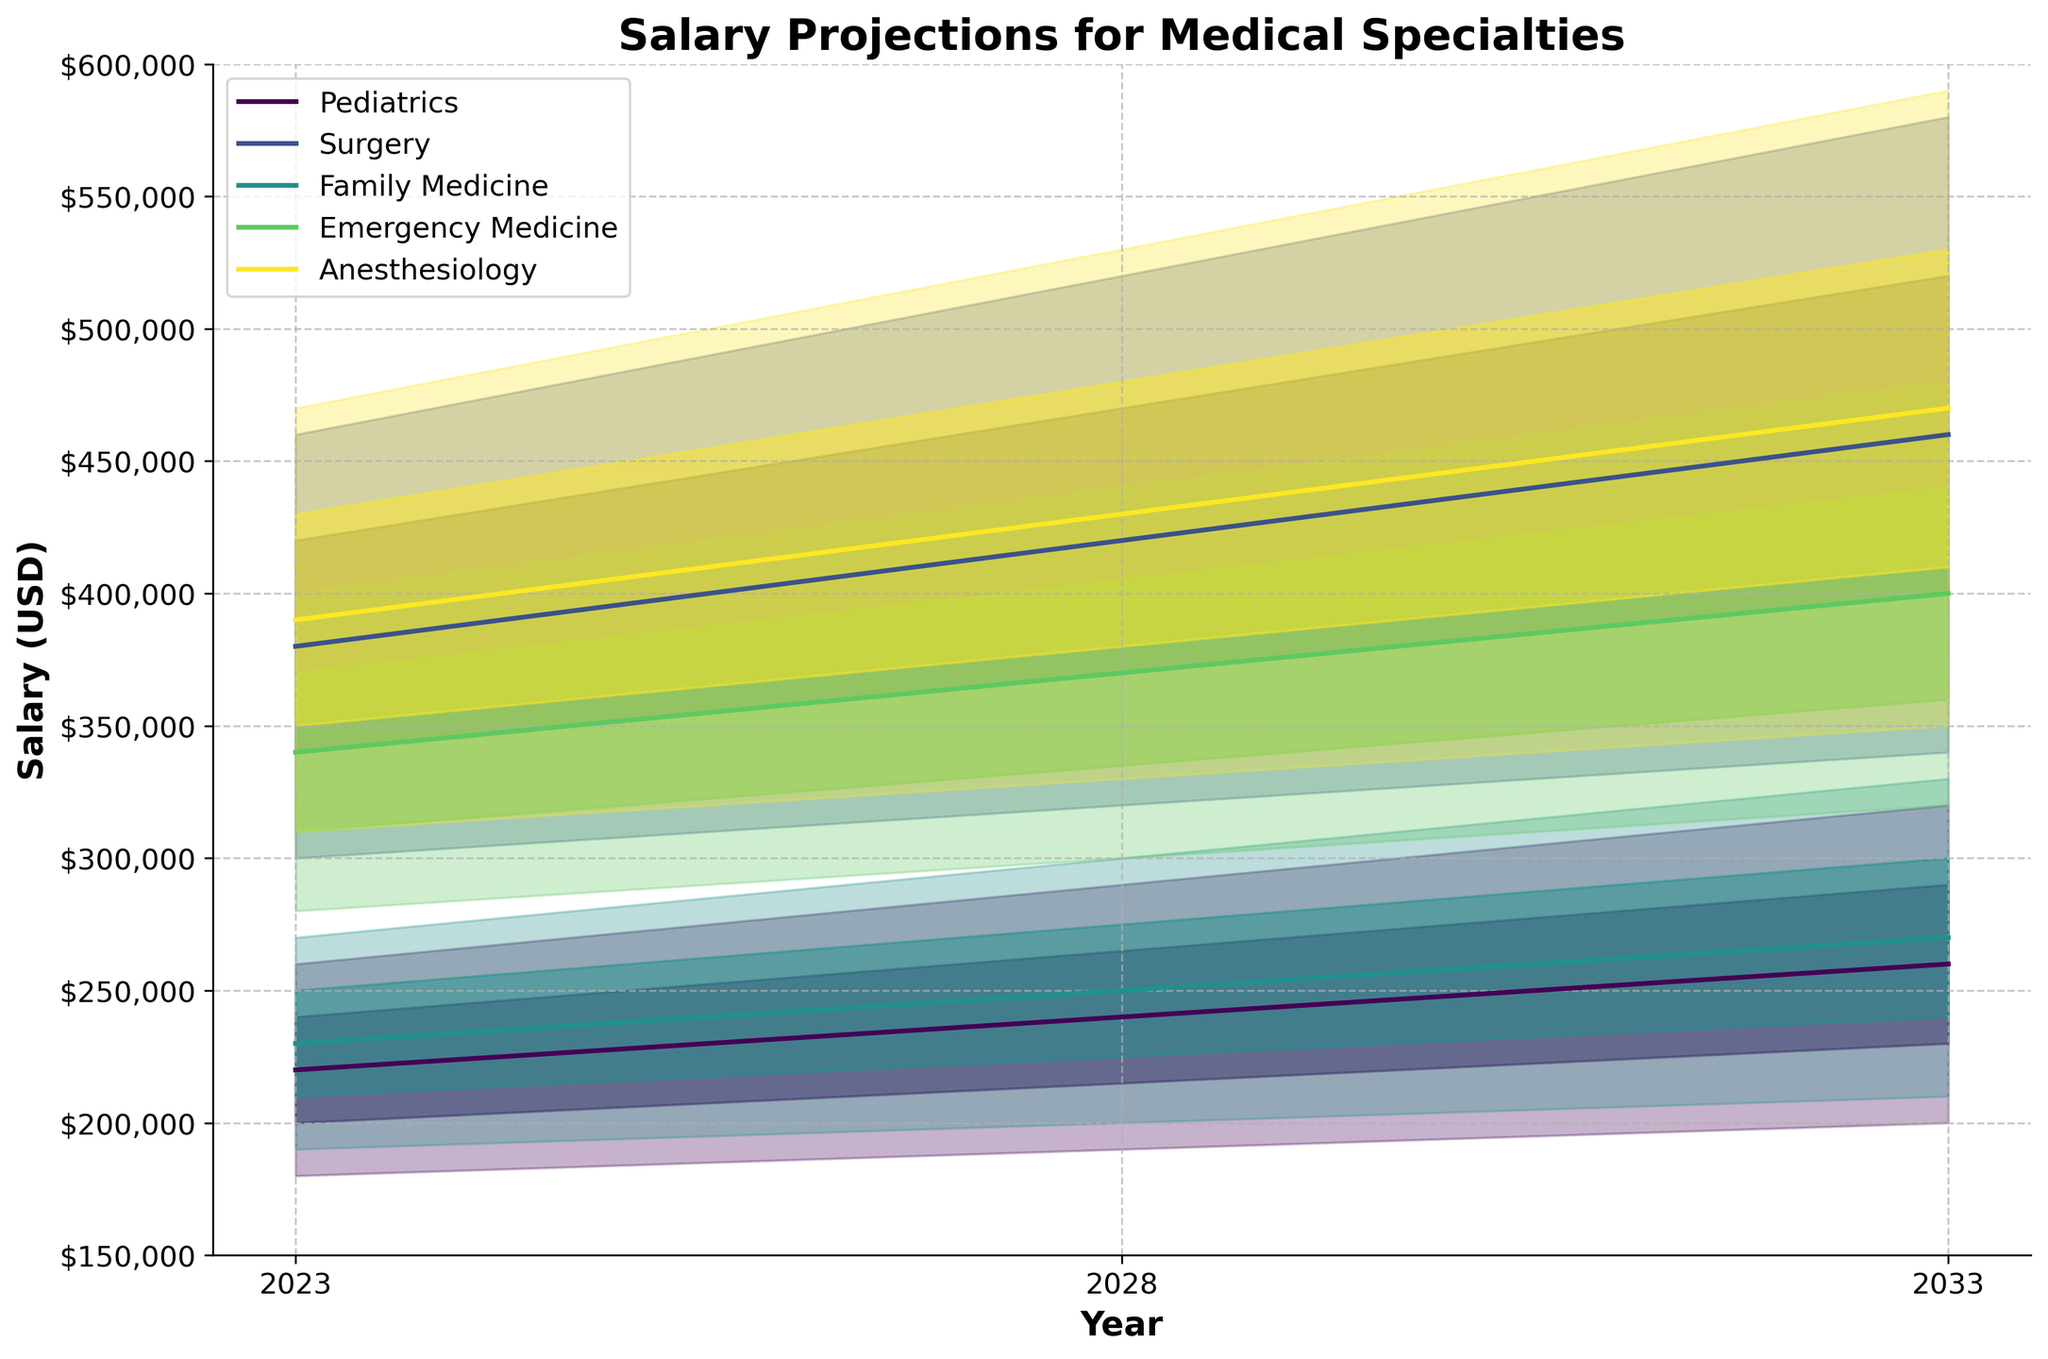What does the plot title say? The title of the plot is located at the top and it states "Salary Projections for Medical Specialties".
Answer: Salary Projections for Medical Specialties What are the five salary levels shown for each year? The fan chart shows salaries at five levels: Low, Low-Mid, Mid, Mid-High, and High, which represent the range of possible earnings for each specialty in a given year.
Answer: Low, Low-Mid, Mid, Mid-High, High Which specialty has the highest salary projection for the year 2023? Looking at the year 2023, compare the salary projections of all specialties at the Mid level. Surgery clearly has the highest projection, with a Mid salary of $380,000.
Answer: Surgery What is the projected mid-range salary for Pediatrics in 2028? Look at the line corresponding to Pediatrics and find the point for the year 2028 at the Mid level. The projected salary here is $240,000.
Answer: $240,000 In which year does Anesthesiology reach a Mid salary projection of $470,000? Find the line representing Anesthesiology and trace it to the point where the Mid level hits $470,000. This occurs in 2033.
Answer: 2033 How does the salary range of Family Medicine in 2033 compare to that in 2023? Compare the Low and High values for Family Medicine in 2023 ($190,000 - $270,000) and in 2033 ($210,000 - $330,000). The range increases from $80,000 to $120,000.
Answer: The range increases by $40,000 from 2023 to 2033 What is the difference in Mid salary projections between Surgery and Emergency Medicine in 2028? For 2028, Surgery has a Mid salary projection of $420,000, while Emergency Medicine has a Mid salary projection of $370,000. The difference is $420,000 - $370,000 = $50,000.
Answer: $50,000 Which specialty shows the greatest salary increase at the Mid level from 2023 to 2033? Calculate the difference in Mid salaries from 2023 to 2033 for each specialty. Surgery increases from $380,000 to $460,000, which is an $80,000 increase. Pediatrics rises from $220,000 to $260,000 ($40,000), Family Medicine from $230,000 to $270,000 ($40,000), Emergency Medicine from $340,000 to $400,000 ($60,000), and Anesthesiology from $390,000 to $470,000 ($80,000). Surgery and Anesthesiology both show the greatest increase of $80,000.
Answer: Surgery and Anesthesiology Which specialty has the most consistent salary range from 2023 to 2033? To determine consistency, compare the spread between Low and High salaries for each specialty over the years. Family Medicine shows the most consistent range, increasing steadily from $190,000 - $270,000 in 2023 to $210,000 - $330,000 in 2033.
Answer: Family Medicine 